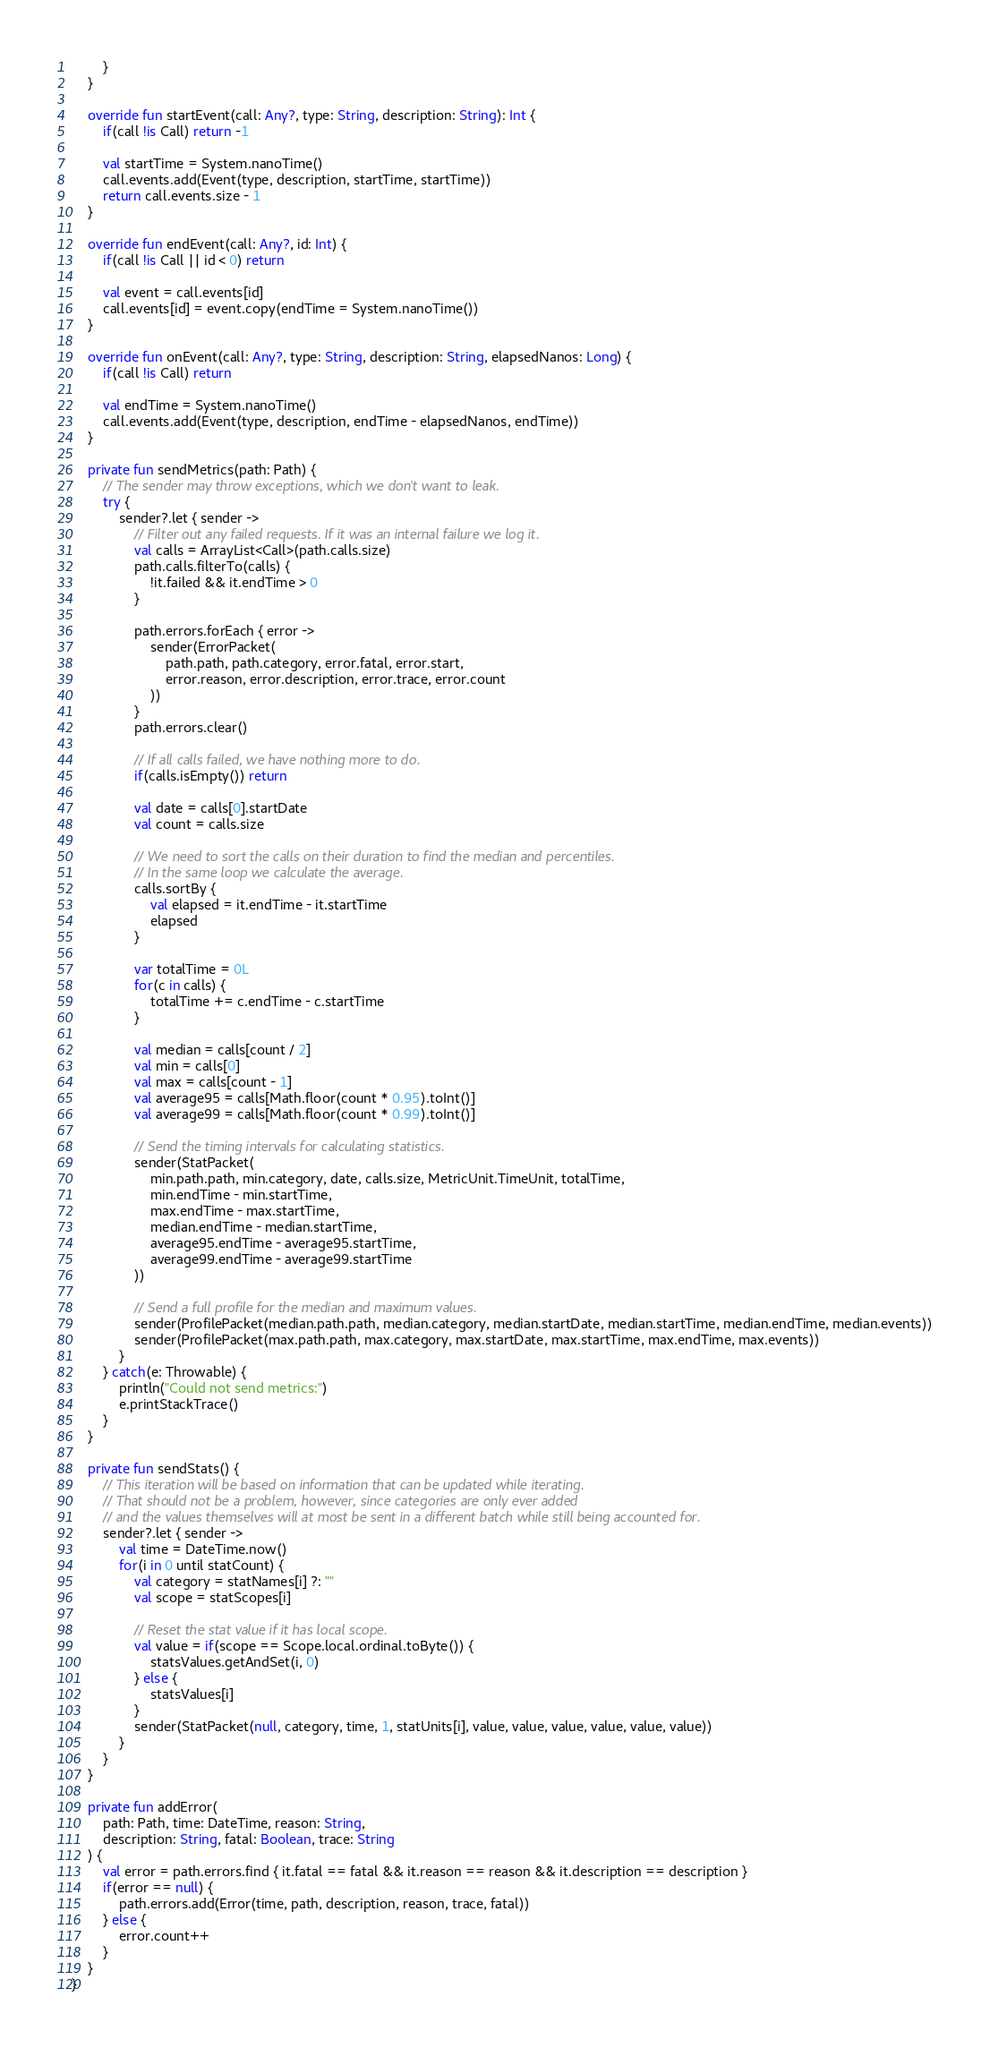<code> <loc_0><loc_0><loc_500><loc_500><_Kotlin_>        }
    }

    override fun startEvent(call: Any?, type: String, description: String): Int {
        if(call !is Call) return -1

        val startTime = System.nanoTime()
        call.events.add(Event(type, description, startTime, startTime))
        return call.events.size - 1
    }

    override fun endEvent(call: Any?, id: Int) {
        if(call !is Call || id < 0) return

        val event = call.events[id]
        call.events[id] = event.copy(endTime = System.nanoTime())
    }

    override fun onEvent(call: Any?, type: String, description: String, elapsedNanos: Long) {
        if(call !is Call) return

        val endTime = System.nanoTime()
        call.events.add(Event(type, description, endTime - elapsedNanos, endTime))
    }

    private fun sendMetrics(path: Path) {
        // The sender may throw exceptions, which we don't want to leak.
        try {
            sender?.let { sender ->
                // Filter out any failed requests. If it was an internal failure we log it.
                val calls = ArrayList<Call>(path.calls.size)
                path.calls.filterTo(calls) {
                    !it.failed && it.endTime > 0
                }

                path.errors.forEach { error ->
                    sender(ErrorPacket(
                        path.path, path.category, error.fatal, error.start,
                        error.reason, error.description, error.trace, error.count
                    ))
                }
                path.errors.clear()

                // If all calls failed, we have nothing more to do.
                if(calls.isEmpty()) return

                val date = calls[0].startDate
                val count = calls.size

                // We need to sort the calls on their duration to find the median and percentiles.
                // In the same loop we calculate the average.
                calls.sortBy {
                    val elapsed = it.endTime - it.startTime
                    elapsed
                }

                var totalTime = 0L
                for(c in calls) {
                    totalTime += c.endTime - c.startTime
                }

                val median = calls[count / 2]
                val min = calls[0]
                val max = calls[count - 1]
                val average95 = calls[Math.floor(count * 0.95).toInt()]
                val average99 = calls[Math.floor(count * 0.99).toInt()]

                // Send the timing intervals for calculating statistics.
                sender(StatPacket(
                    min.path.path, min.category, date, calls.size, MetricUnit.TimeUnit, totalTime,
                    min.endTime - min.startTime,
                    max.endTime - max.startTime,
                    median.endTime - median.startTime,
                    average95.endTime - average95.startTime,
                    average99.endTime - average99.startTime
                ))

                // Send a full profile for the median and maximum values.
                sender(ProfilePacket(median.path.path, median.category, median.startDate, median.startTime, median.endTime, median.events))
                sender(ProfilePacket(max.path.path, max.category, max.startDate, max.startTime, max.endTime, max.events))
            }
        } catch(e: Throwable) {
            println("Could not send metrics:")
            e.printStackTrace()
        }
    }

    private fun sendStats() {
        // This iteration will be based on information that can be updated while iterating.
        // That should not be a problem, however, since categories are only ever added
        // and the values themselves will at most be sent in a different batch while still being accounted for.
        sender?.let { sender ->
            val time = DateTime.now()
            for(i in 0 until statCount) {
                val category = statNames[i] ?: ""
                val scope = statScopes[i]

                // Reset the stat value if it has local scope.
                val value = if(scope == Scope.local.ordinal.toByte()) {
                    statsValues.getAndSet(i, 0)
                } else {
                    statsValues[i]
                }
                sender(StatPacket(null, category, time, 1, statUnits[i], value, value, value, value, value, value))
            }
        }
    }

    private fun addError(
        path: Path, time: DateTime, reason: String,
        description: String, fatal: Boolean, trace: String
    ) {
        val error = path.errors.find { it.fatal == fatal && it.reason == reason && it.description == description }
        if(error == null) {
            path.errors.add(Error(time, path, description, reason, trace, fatal))
        } else {
            error.count++
        }
    }
}</code> 